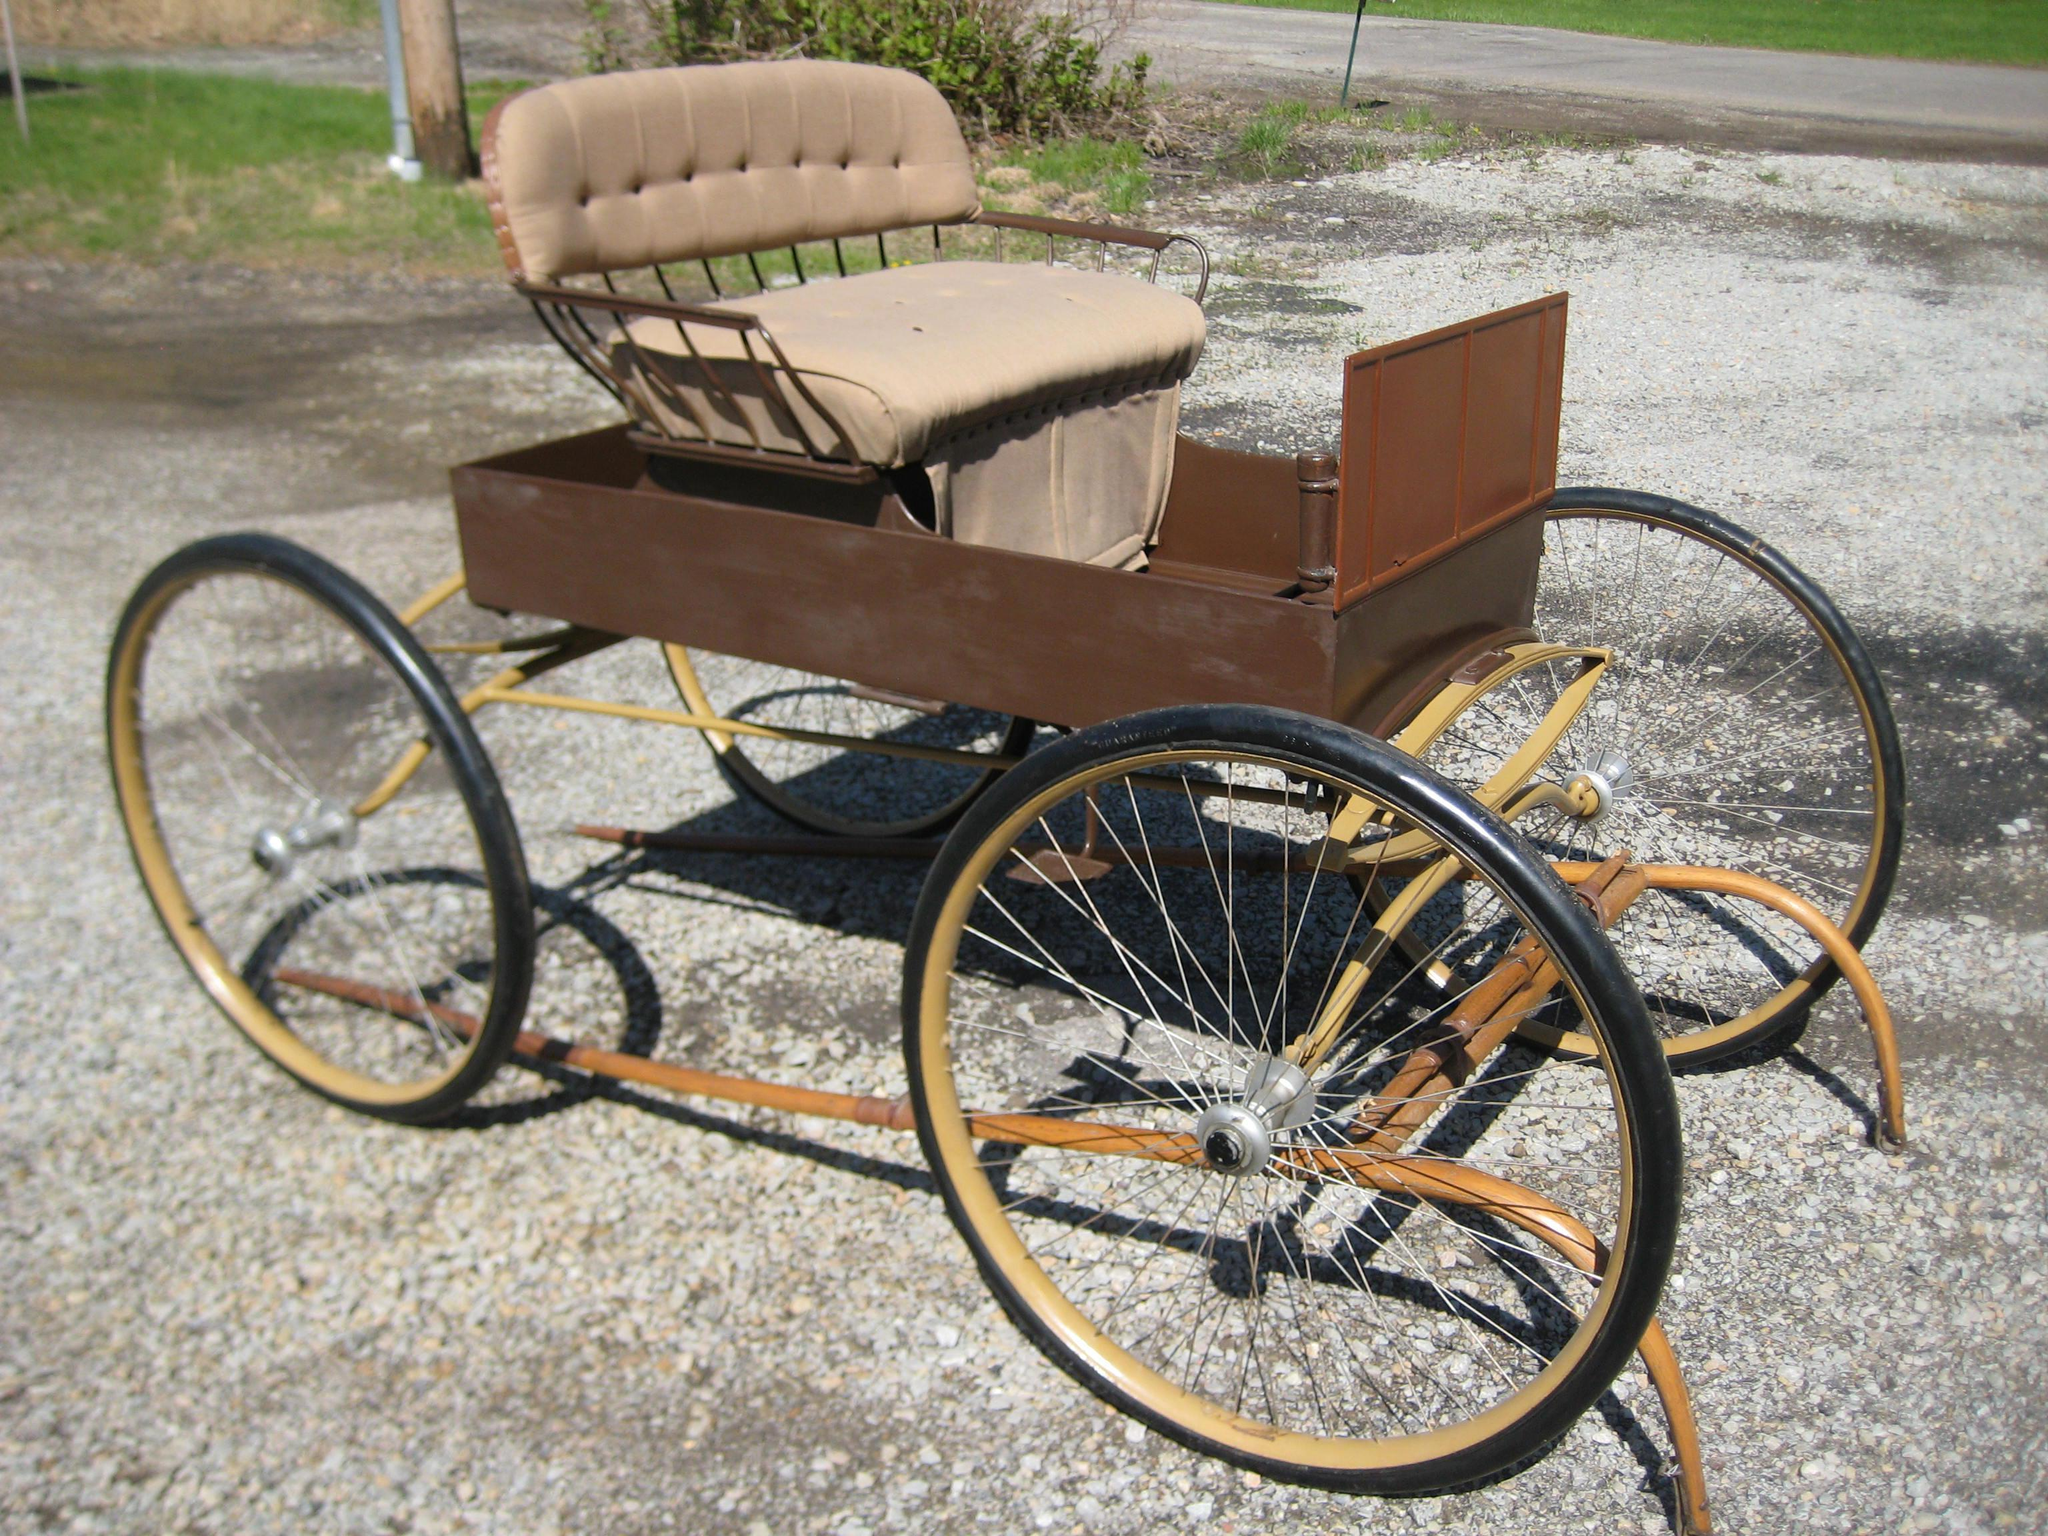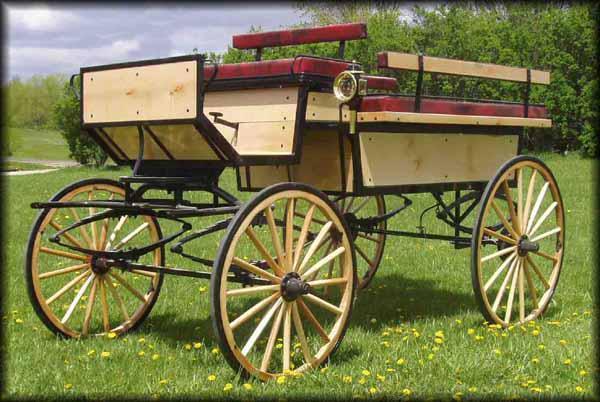The first image is the image on the left, the second image is the image on the right. Considering the images on both sides, is "An image features a four-wheeled cart with distinctly smaller wheels at the front." valid? Answer yes or no. No. 